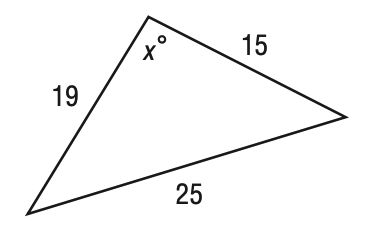Question: Find x in the figure below. Round your answer to the nearest tenth if necessary.
Choices:
A. 91.9
B. 93.9
C. 95.9
D. 97.9
Answer with the letter. Answer: B 